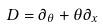<formula> <loc_0><loc_0><loc_500><loc_500>D = \partial _ { \theta } + \theta \partial _ { x }</formula> 